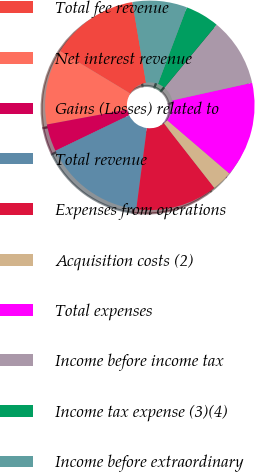Convert chart to OTSL. <chart><loc_0><loc_0><loc_500><loc_500><pie_chart><fcel>Total fee revenue<fcel>Net interest revenue<fcel>Gains (Losses) related to<fcel>Total revenue<fcel>Expenses from operations<fcel>Acquisition costs (2)<fcel>Total expenses<fcel>Income before income tax<fcel>Income tax expense (3)(4)<fcel>Income before extraordinary<nl><fcel>13.68%<fcel>11.58%<fcel>4.21%<fcel>15.79%<fcel>12.63%<fcel>3.16%<fcel>14.74%<fcel>10.53%<fcel>5.26%<fcel>8.42%<nl></chart> 